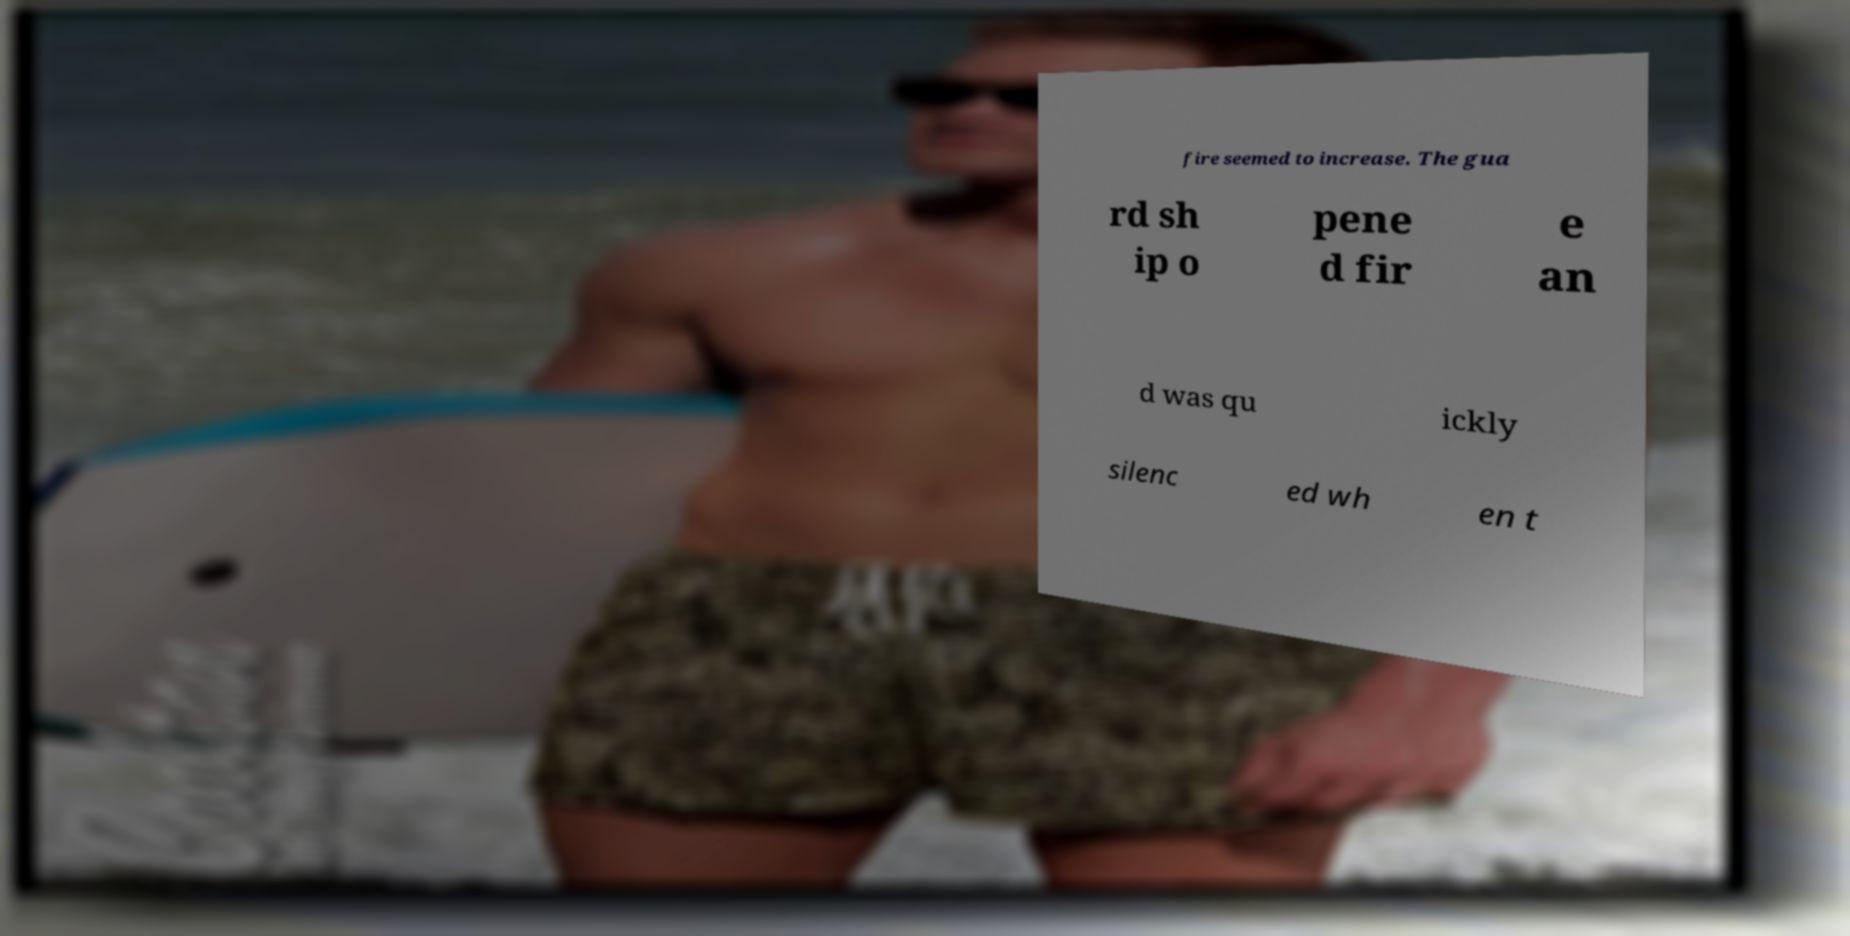Could you assist in decoding the text presented in this image and type it out clearly? fire seemed to increase. The gua rd sh ip o pene d fir e an d was qu ickly silenc ed wh en t 